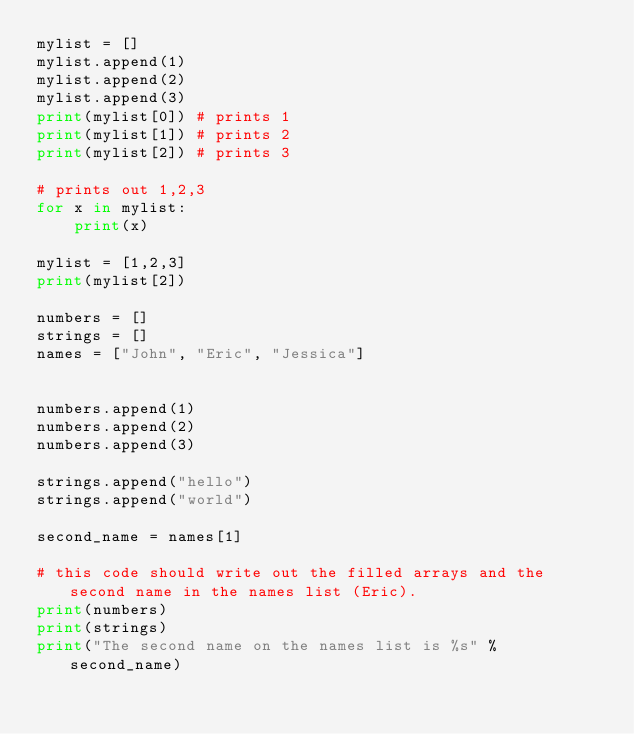Convert code to text. <code><loc_0><loc_0><loc_500><loc_500><_Python_>mylist = []
mylist.append(1)
mylist.append(2)
mylist.append(3)
print(mylist[0]) # prints 1
print(mylist[1]) # prints 2
print(mylist[2]) # prints 3

# prints out 1,2,3
for x in mylist:
    print(x)

mylist = [1,2,3]
print(mylist[2])

numbers = []
strings = []
names = ["John", "Eric", "Jessica"]


numbers.append(1)
numbers.append(2)
numbers.append(3)

strings.append("hello")
strings.append("world")

second_name = names[1]

# this code should write out the filled arrays and the second name in the names list (Eric).
print(numbers)
print(strings)
print("The second name on the names list is %s" % second_name)</code> 